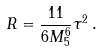<formula> <loc_0><loc_0><loc_500><loc_500>R = \frac { 1 1 } { 6 M _ { 5 } ^ { 6 } } \tau ^ { 2 } \, .</formula> 